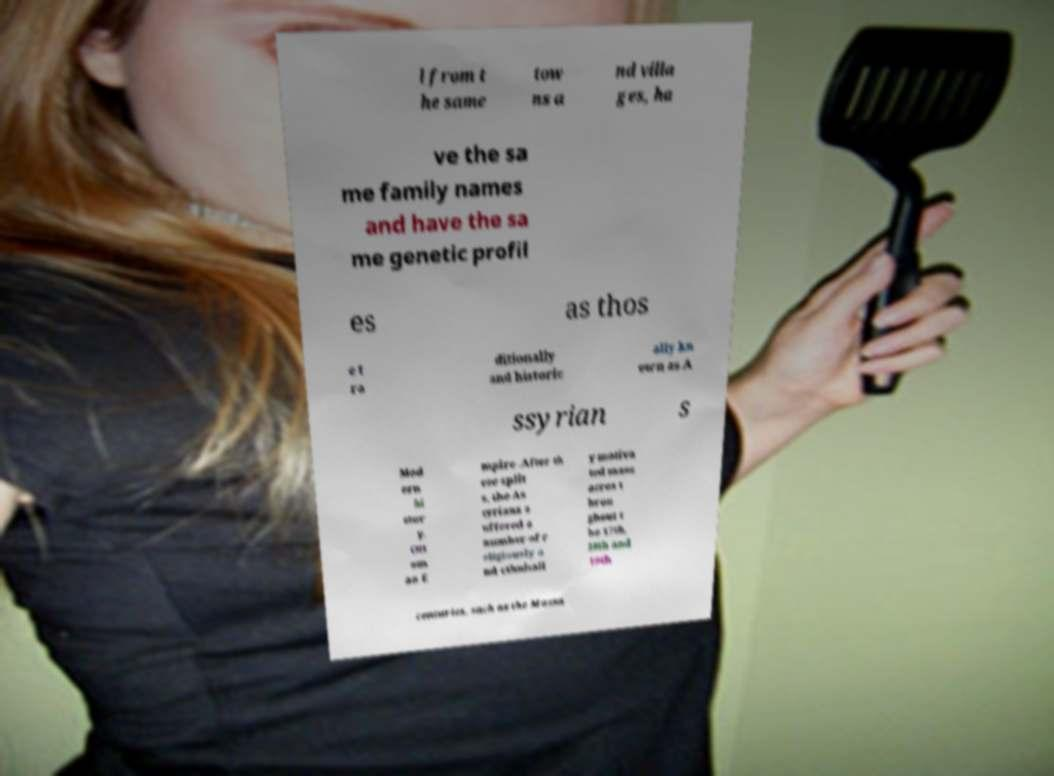Please read and relay the text visible in this image. What does it say? l from t he same tow ns a nd villa ges, ha ve the sa me family names and have the sa me genetic profil es as thos e t ra ditionally and historic ally kn own as A ssyrian s Mod ern hi stor y. Ott om an E mpire .After th ese split s, the As syrians s uffered a number of r eligiously a nd ethnicall y motiva ted mass acres t hrou ghout t he 17th, 18th and 19th centuries, such as the Massa 